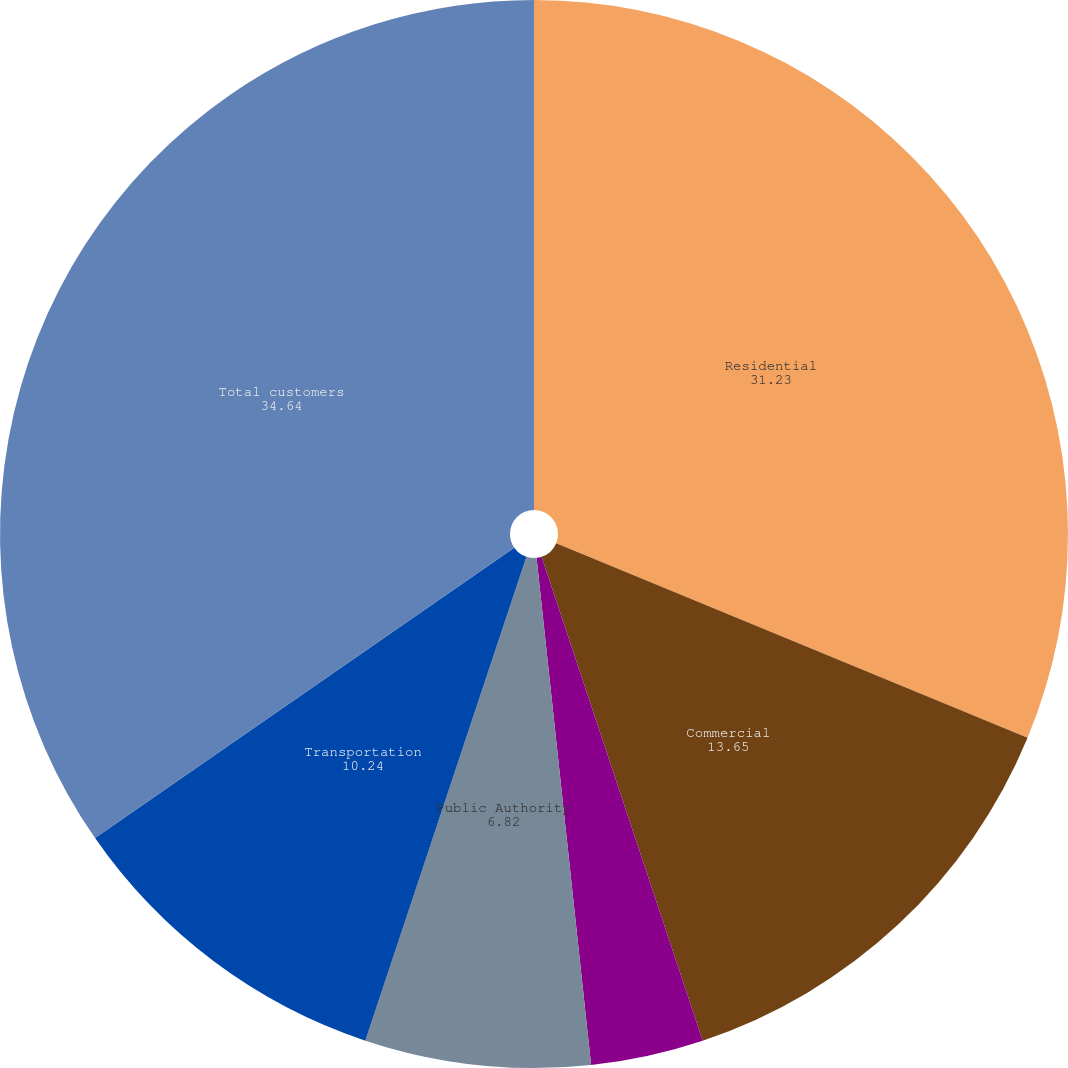<chart> <loc_0><loc_0><loc_500><loc_500><pie_chart><fcel>Residential<fcel>Commercial<fcel>Industrial<fcel>Wholesale<fcel>Public Authority<fcel>Transportation<fcel>Total customers<nl><fcel>31.23%<fcel>13.65%<fcel>3.41%<fcel>0.0%<fcel>6.82%<fcel>10.24%<fcel>34.64%<nl></chart> 